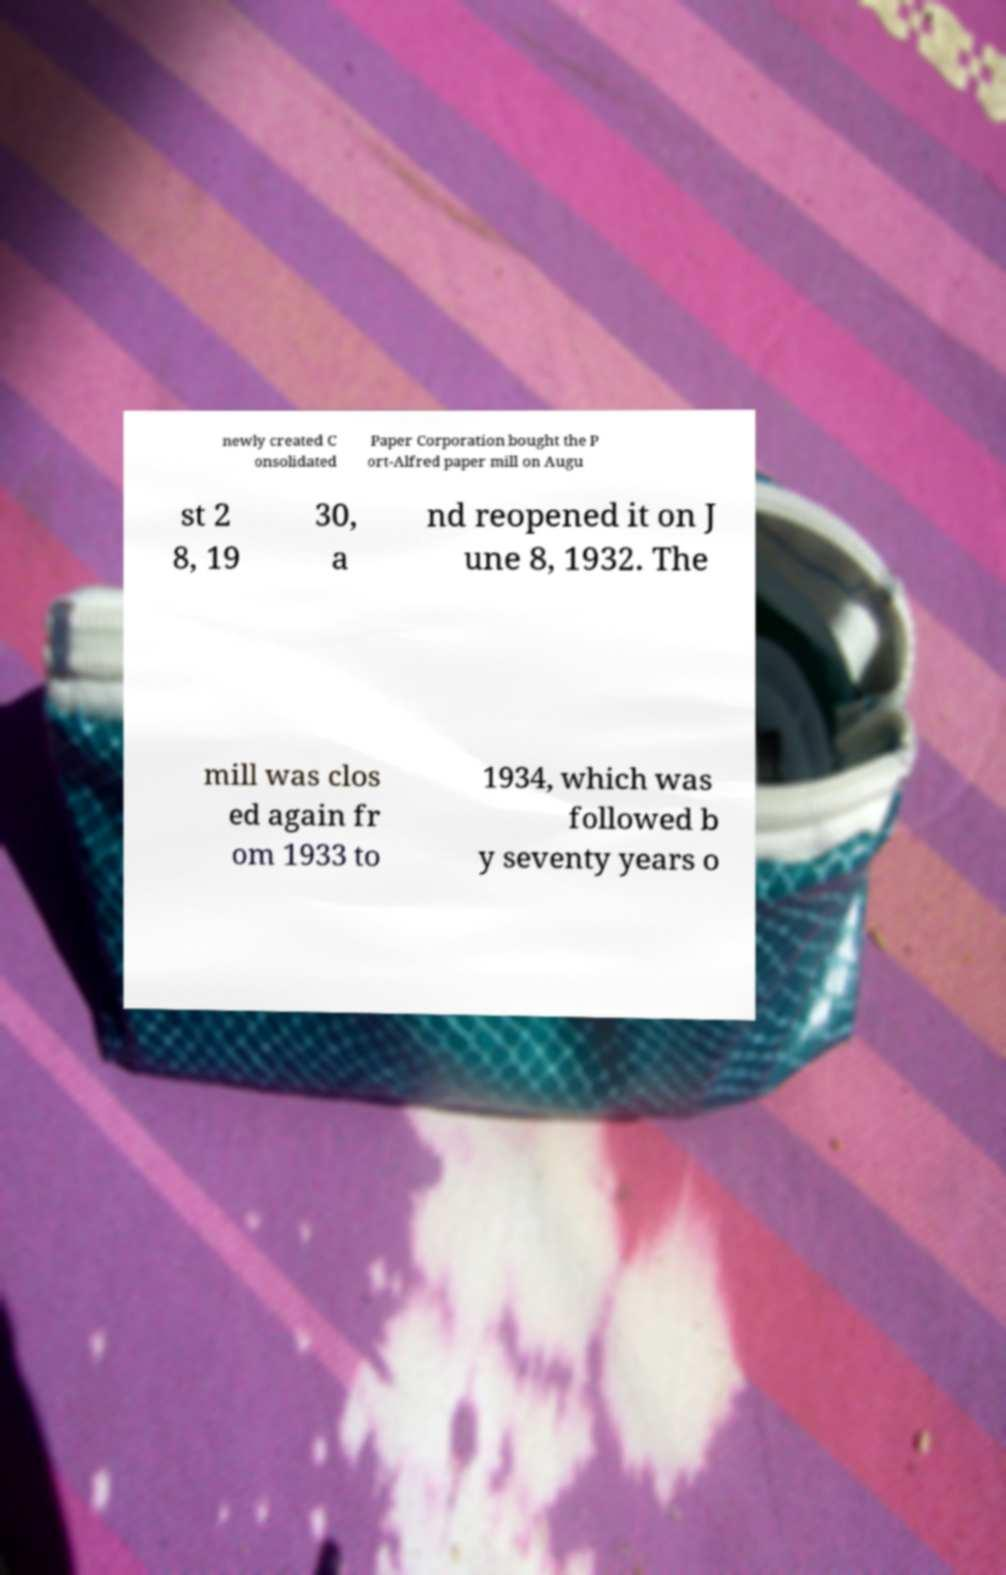Can you accurately transcribe the text from the provided image for me? newly created C onsolidated Paper Corporation bought the P ort-Alfred paper mill on Augu st 2 8, 19 30, a nd reopened it on J une 8, 1932. The mill was clos ed again fr om 1933 to 1934, which was followed b y seventy years o 